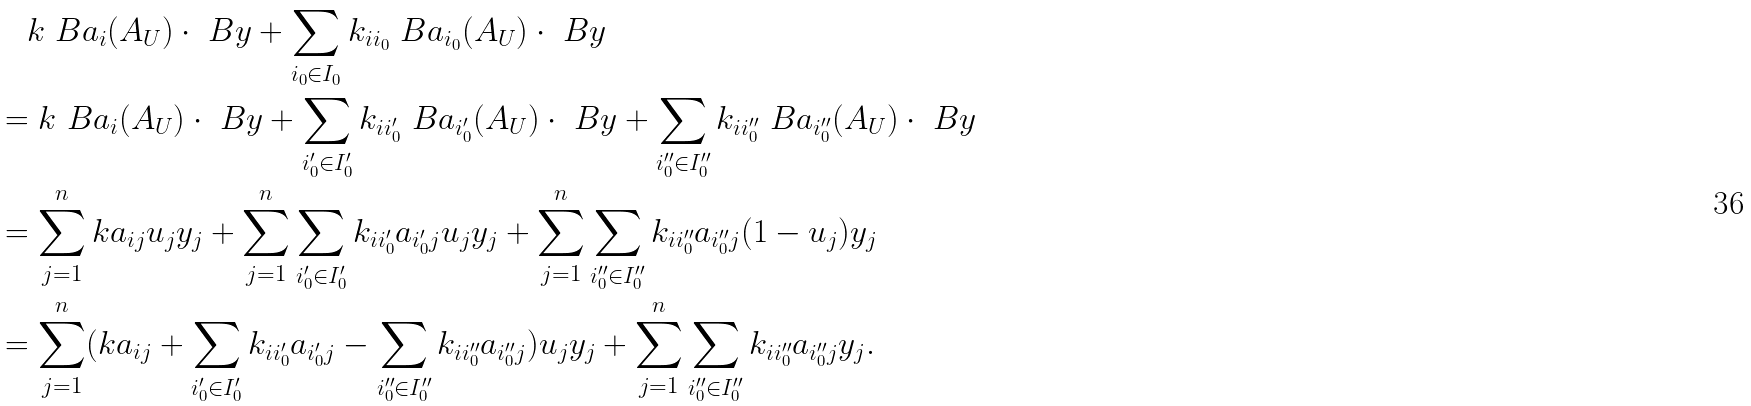Convert formula to latex. <formula><loc_0><loc_0><loc_500><loc_500>& \quad k \ B a _ { i } ( A _ { U } ) \cdot \ B y + \sum _ { i _ { 0 } \in I _ { 0 } } k _ { i i _ { 0 } } \ B a _ { i _ { 0 } } ( A _ { U } ) \cdot \ B y \\ & = k \ B a _ { i } ( A _ { U } ) \cdot \ B y + \sum _ { i _ { 0 } ^ { \prime } \in I _ { 0 } ^ { \prime } } k _ { i i _ { 0 } ^ { \prime } } \ B a _ { i _ { 0 } ^ { \prime } } ( A _ { U } ) \cdot \ B y + \sum _ { i _ { 0 } ^ { \prime \prime } \in I _ { 0 } ^ { \prime \prime } } k _ { i i _ { 0 } ^ { \prime \prime } } \ B a _ { i _ { 0 } ^ { \prime \prime } } ( A _ { U } ) \cdot \ B y \\ & = \sum _ { j = 1 } ^ { n } k a _ { i j } u _ { j } y _ { j } + \sum _ { j = 1 } ^ { n } \sum _ { i _ { 0 } ^ { \prime } \in I _ { 0 } ^ { \prime } } k _ { i i _ { 0 } ^ { \prime } } a _ { i _ { 0 } ^ { \prime } j } u _ { j } y _ { j } + \sum _ { j = 1 } ^ { n } \sum _ { i _ { 0 } ^ { \prime \prime } \in I _ { 0 } ^ { \prime \prime } } k _ { i i _ { 0 } ^ { \prime \prime } } a _ { i _ { 0 } ^ { \prime \prime } j } ( 1 - u _ { j } ) y _ { j } \\ & = \sum _ { j = 1 } ^ { n } ( k a _ { i j } + \sum _ { i _ { 0 } ^ { \prime } \in I _ { 0 } ^ { \prime } } k _ { i i _ { 0 } ^ { \prime } } a _ { i _ { 0 } ^ { \prime } j } - \sum _ { i _ { 0 } ^ { \prime \prime } \in I _ { 0 } ^ { \prime \prime } } k _ { i i _ { 0 } ^ { \prime \prime } } a _ { i _ { 0 } ^ { \prime \prime } j } ) u _ { j } y _ { j } + \sum _ { j = 1 } ^ { n } \sum _ { i _ { 0 } ^ { \prime \prime } \in I _ { 0 } ^ { \prime \prime } } k _ { i i _ { 0 } ^ { \prime \prime } } a _ { i _ { 0 } ^ { \prime \prime } j } y _ { j } .</formula> 